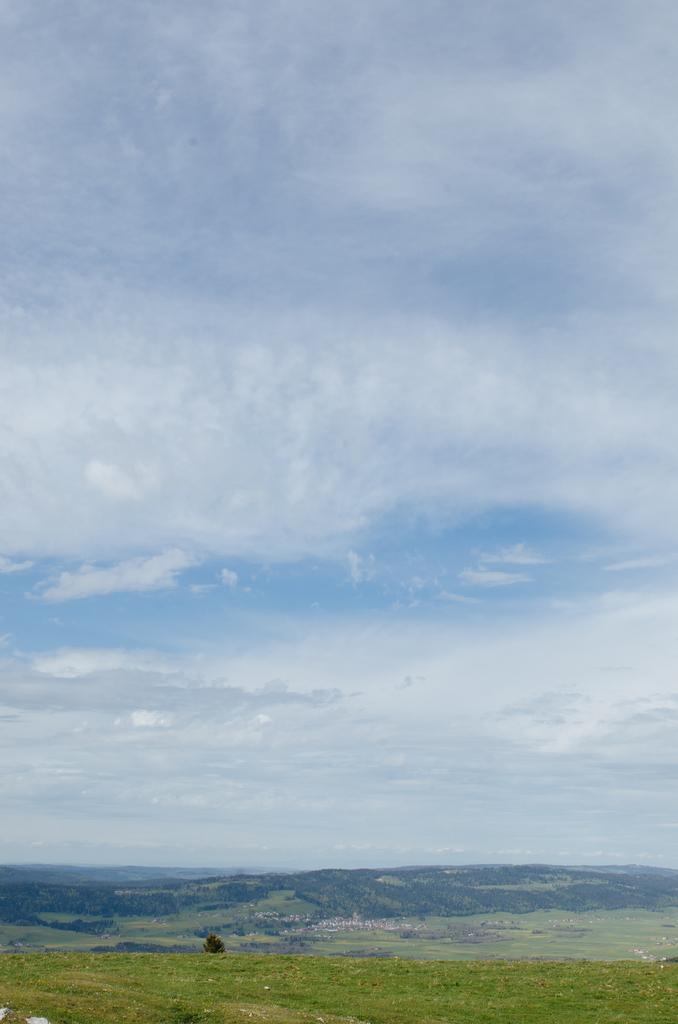Please provide a concise description of this image. In this picture there are mountains and there is a tree in the foreground. At the top there is sky and there are clouds. At the bottom there is grass. 